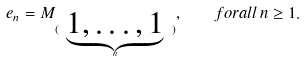<formula> <loc_0><loc_0><loc_500><loc_500>e _ { n } = M _ { ( \ \underbrace { 1 , \dots , 1 } _ { n } \ ) } , \quad f o r a l l \, n \geq 1 .</formula> 